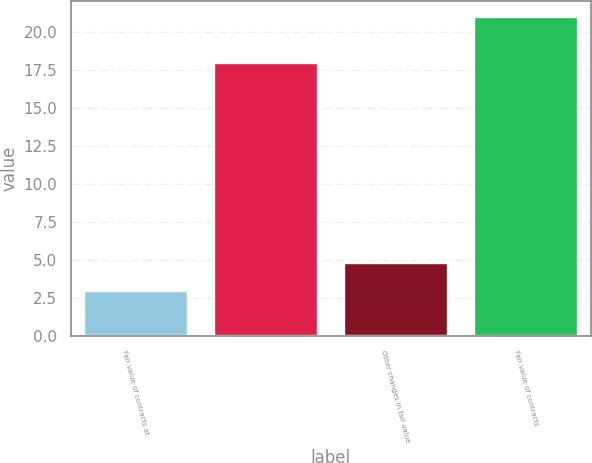Convert chart. <chart><loc_0><loc_0><loc_500><loc_500><bar_chart><fcel>Fair value of contracts at<fcel>Unnamed: 1<fcel>Other changes in fair value<fcel>Fair value of contracts<nl><fcel>3<fcel>18<fcel>4.8<fcel>21<nl></chart> 